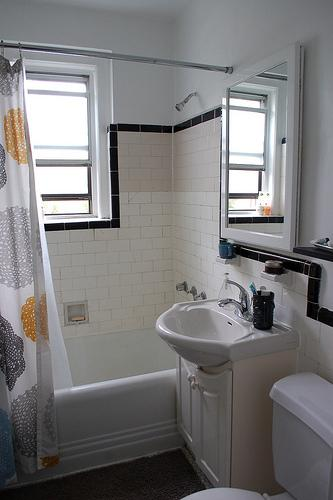Analyze the positions of objects in relation to the sink, such as those above, below, or beside it. Above the sink, there is a clean mirror, a mirrored medicine cabinet, and a blue cup on the ledge. Below the sink, there are white cabinets and two little doors. Beside the sink, there is a black toothbrush holder and a soap dispenser. Identify the items found in the image related to personal hygiene. shower curtain, shower head, sink, sink faucet, toilet tank, toothbrush holder, handwash, toilet, bath mat, toothbrushes, soap holder, soap, bath wash, soap dispenser Investigate the reasoning behind the placement of the black bath mat in the bathroom. The black bath mat is strategically placed on the floor to absorb water and provide a non-slip surface for stepping out of the shower or tub safely. Describe the setup and appearance of the shower area. The shower area has a grey, orange, and white curtain, a silver metal shower head, and a silver metal shower curtain rod. The wall is tiled with white and off-white tiles and has a white and black tile trim. The shower is made of tile, and a window is in the shower. Elaborate on the appearance and color scheme of the bathroom tiles. The bathroom tiles are ivory ceramic and white subway tiles, with some featuring black tile as trim. Enumerate the items found in the image that are placed in a cabinet or under the sink. white wooden bathroom cabinet, white cabinets under sink, two little doors under the white handwash What material is the shower curtain rod made of, and what is its color? The shower curtain rod is made of silver metal. Count the total number of circles seen on the white shower curtain. There are four circles on the white shower curtain: two yellow circles and two others with different colors. Provide an overview of the image sentiment by describing the atmosphere and condition of the bathroom. The bathroom is clean, well-maintained, and organized, evoking a sense of freshness and orderliness. Based on the image quality, what kind of setting does the bathroom seem to be in? The image quality suggests a residential bathroom setting, possibly in a modern apartment or house. Is the shower curtain hanging or lying on the floor? hanging Identify the contents of the black cup. toothbrushes Explain the look of the mirror in the bathroom. The mirror is framed in white and is clean. State the type and color of the soap holder. Ivory ceramic soap holder What is the color and material of the toilet? white and ceramic Which type of tiles form the shower area? white subway tiles What is the primary color of the rug on the floor? black Locate an object in the image that is orange in color. orange bar of soap What color is the shower curtain? grey, orange, and white What can be seen in the mirror? Nothing specific can be seen in the mirror, it's clean and reflective. Is the window open or closed? closed Describe the appearance of the bathroom tiles. Ivory and white ceramic tiles with off white and black trim Which of the following objects are silver? (a) shower curtain rod (b) sink faucet (c) toothbrush holder (d) handwash a) shower curtain rod, and b) sink faucet What is the color of the toothbrush holder and its position with respect to the sink? black toothbrush holder on the sink Determine the type and color of the item near the bottom left of the image. black bath mat Spot the two objects located above the handwash. clean mirror and white framed mirrored medicine cabinet Find out which object is silver and made of metal near the sink. sink faucet What can be found on the bathroom ledge? blue cup List the items located inside the bathtub. white big window, part of white clean toilet, and two bottles of bath wash 